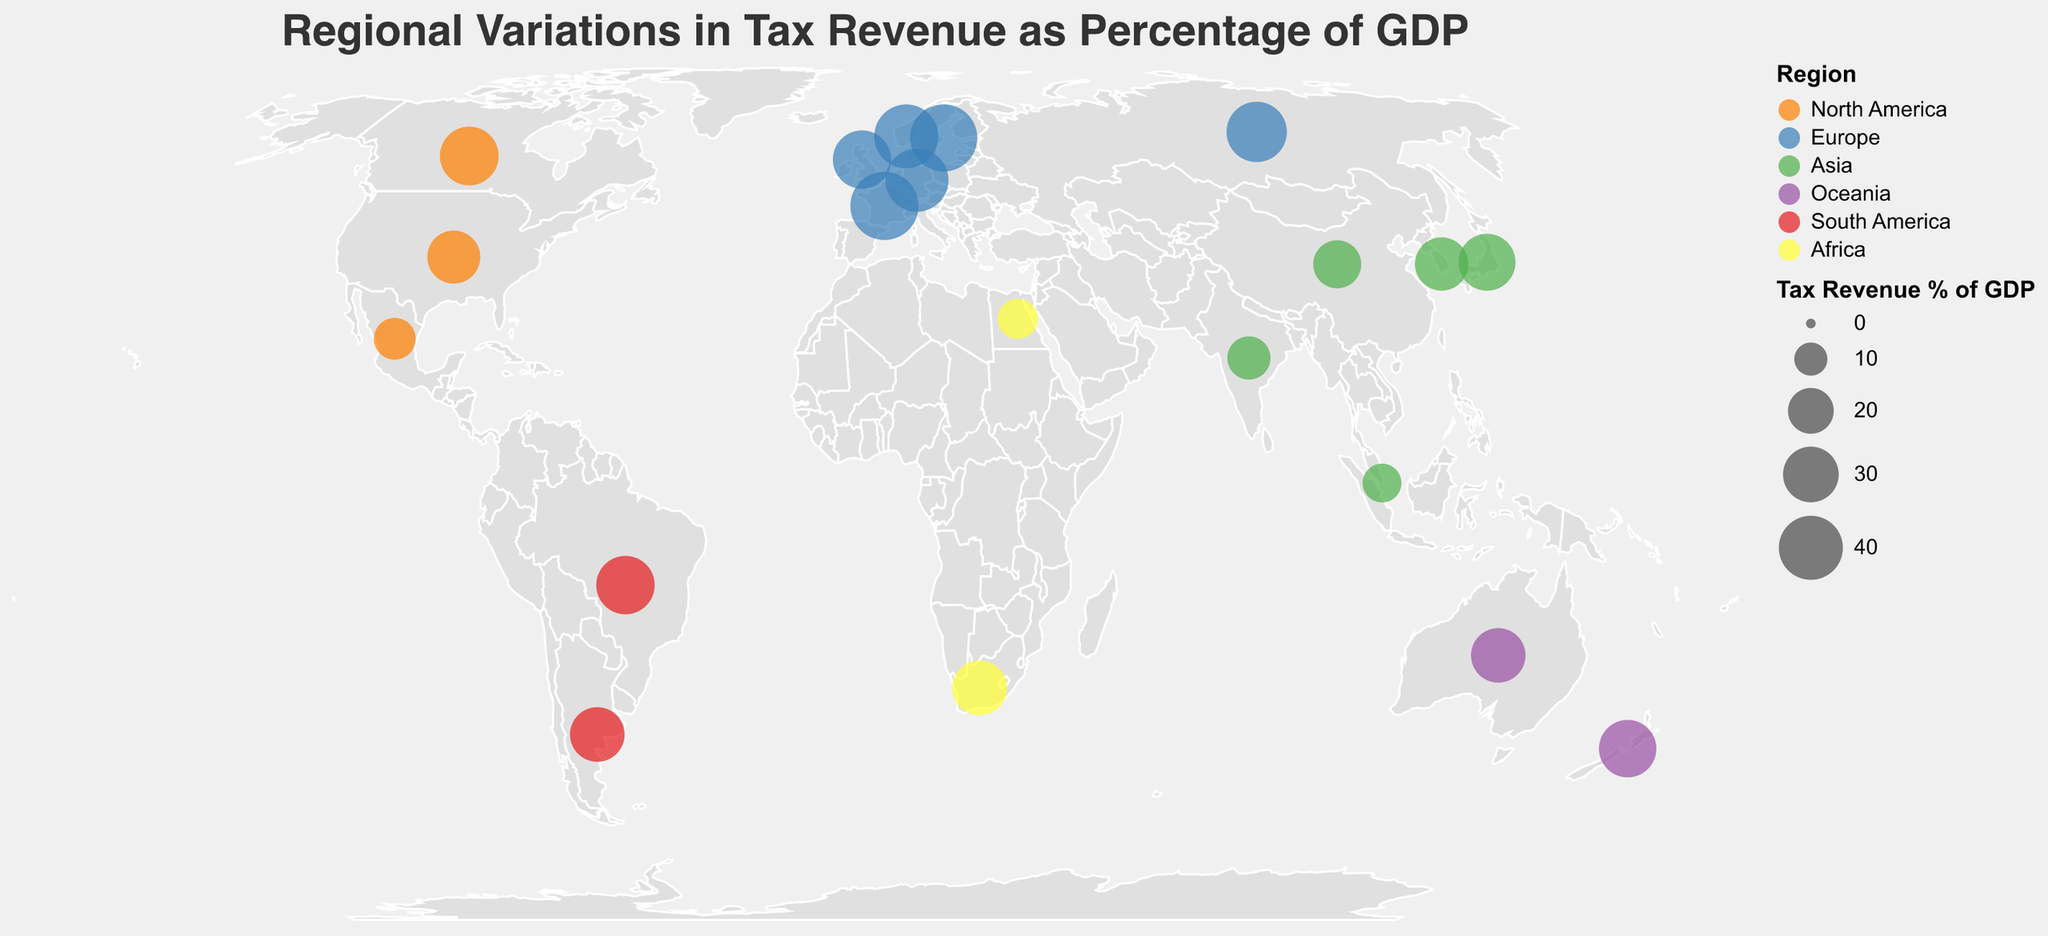What is the title of the figure? The title is placed at the top of the figure and reads "Regional Variations in Tax Revenue as Percentage of GDP."
Answer: Regional Variations in Tax Revenue as Percentage of GDP How many regions are represented in the figure? The color legend categorizes data points into different regions, and there are six distinct colors listed.
Answer: Six Which country in Asia has the highest percentage of tax revenue to GDP and what is the value? Looking at the data points in the Asia region (green dots), the highest percentage is 31.4 for Japan.
Answer: Japan, 31.4 Among countries in Europe, which country has the lowest tax revenue percentage of GDP? Reviewing the data points in the Europe region (blue dots), the lowest tax revenue percentage of GDP is 33.0 for the United Kingdom.
Answer: United Kingdom What is the average tax revenue percentage of GDP in Oceania region? The countries in the Oceania region are Australia (28.7) and New Zealand (32.0). The average is (28.7 + 32.0) / 2 = 60.7 / 2 = 30.35.
Answer: 30.35 How does the tax revenue percentage of GDP in France compare to that in Germany? France has a tax revenue percentage of 45.4, while Germany has 38.8. France's tax revenue percentage is higher than Germany's.
Answer: France > Germany Which country has the lowest tax revenue percentage of GDP across all regions? The tooltip reveals that Singapore in Asia has the lowest value listed at 14.1.
Answer: Singapore Among the North American countries, what is the difference in tax revenue percentage of GDP between Canada and the United States? Canada's tax revenue percentage is 33.5, and the United States is 27.1. The difference is 33.5 - 27.1 = 6.4.
Answer: 6.4 Which country in Africa has the higher tax revenue percentage of GDP, South Africa or Egypt? South Africa and Egypt are the two African countries listed; South Africa has 29.1, and Egypt has 15.2. Therefore, South Africa has a higher percentage.
Answer: South Africa If you sum up the tax revenue percentages of all South American countries in the figure, what is the total value? Brazil has 33.1, and Argentina has 28.8. The sum is 33.1 + 28.8 = 61.9.
Answer: 61.9 